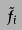Convert formula to latex. <formula><loc_0><loc_0><loc_500><loc_500>\tilde { f } _ { i }</formula> 